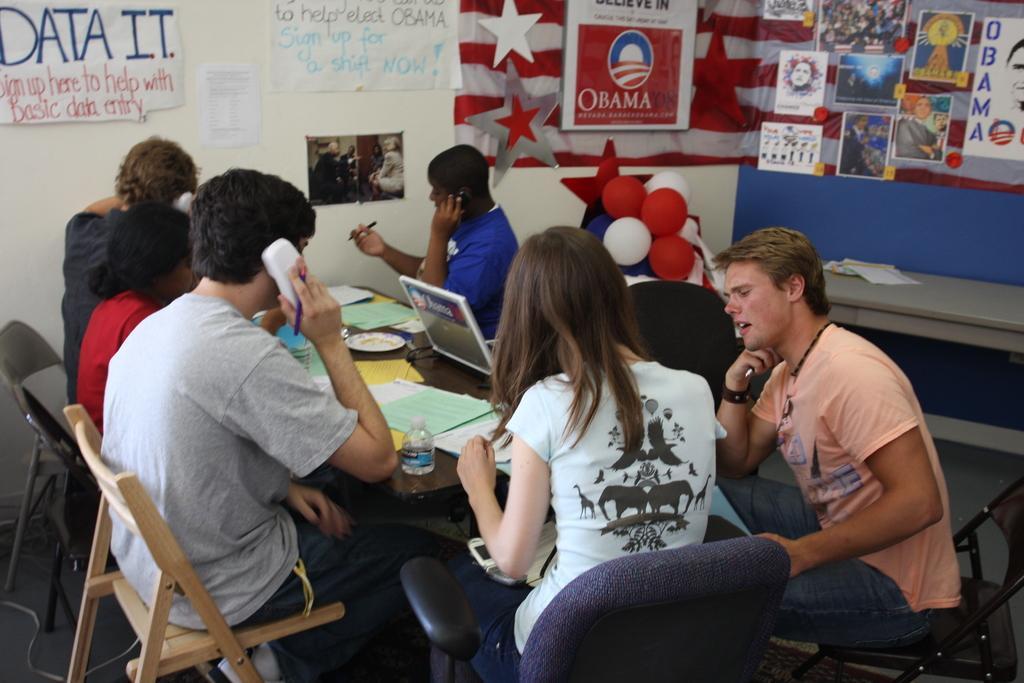In one or two sentences, can you explain what this image depicts? Here we can see a group of people are sitting on the chair, and in front here is the table and papers and laptop on it, and here is the wall, and here is the balloons. 